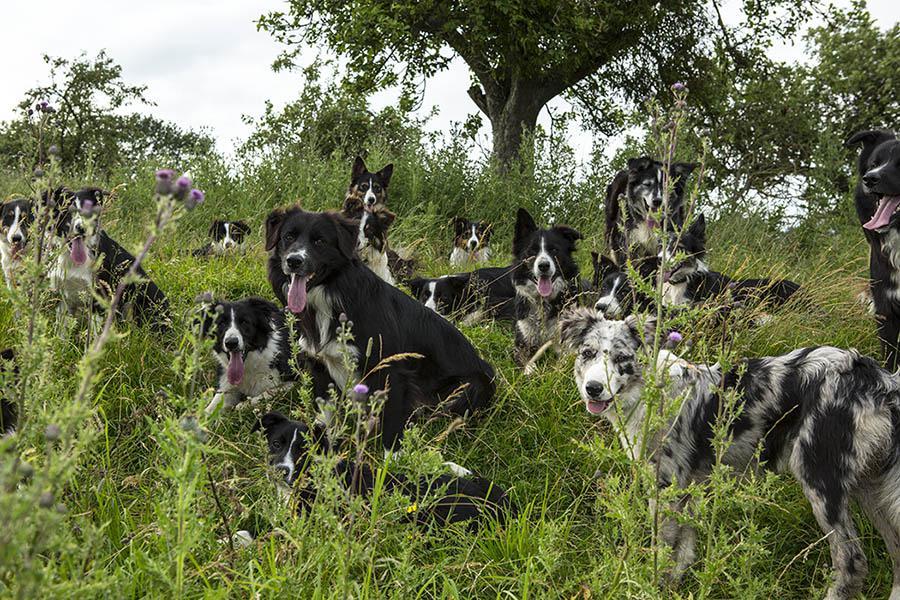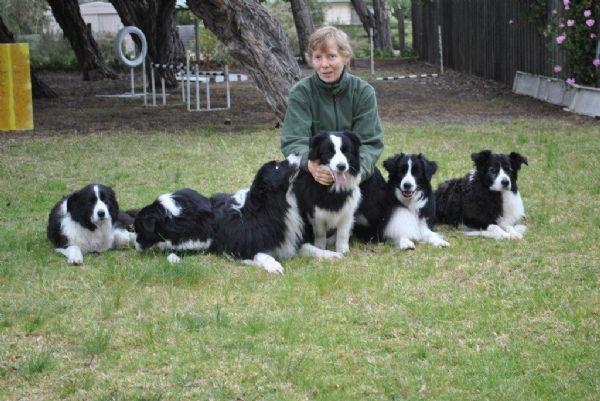The first image is the image on the left, the second image is the image on the right. Assess this claim about the two images: "One image includes a dog running toward the camera, and the other image shows reclining dogs, with some kind of heaped plant material in a horizontal row.". Correct or not? Answer yes or no. No. 